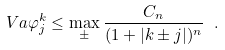Convert formula to latex. <formula><loc_0><loc_0><loc_500><loc_500>\ V a { \varphi _ { j } ^ { k } } \leq \max _ { \pm } \frac { C _ { n } } { ( 1 + | k \pm j | ) ^ { n } } \ .</formula> 